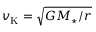Convert formula to latex. <formula><loc_0><loc_0><loc_500><loc_500>v _ { K } = \sqrt { G M _ { ^ { * } } / r }</formula> 